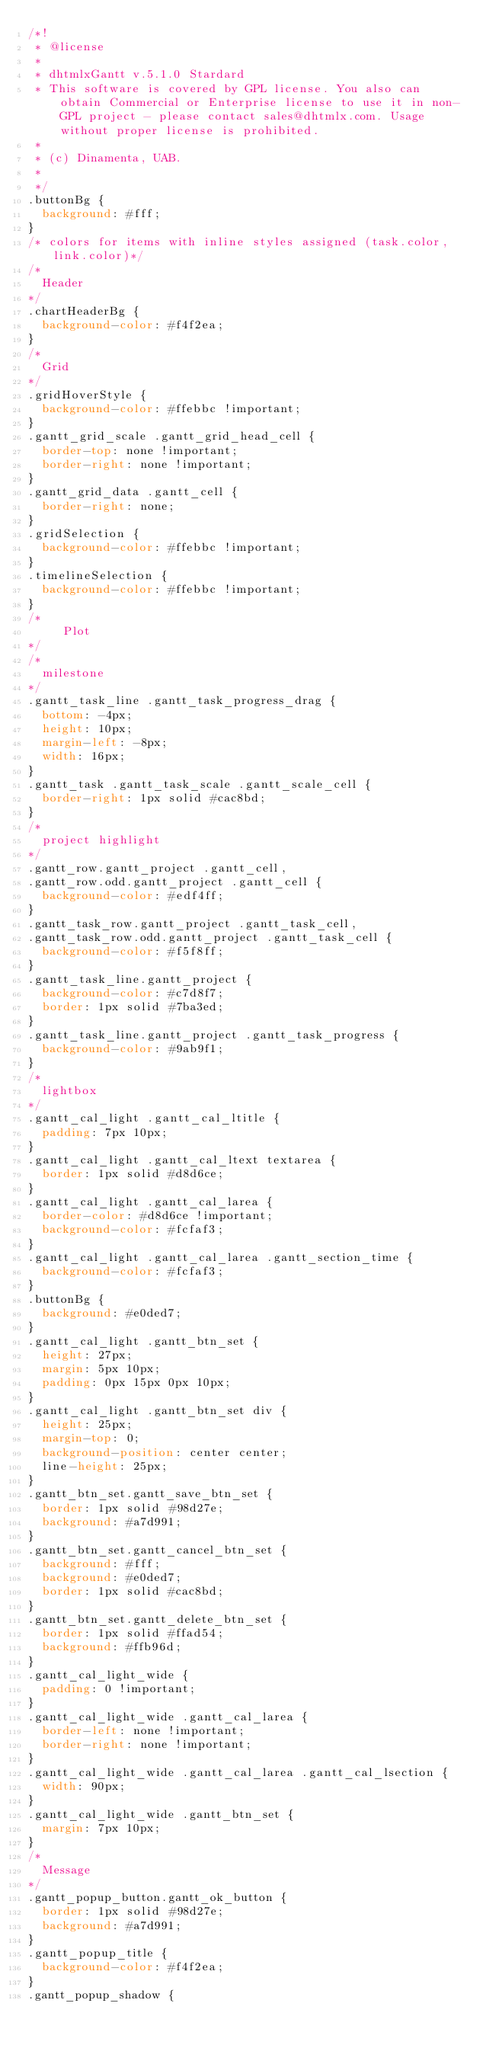<code> <loc_0><loc_0><loc_500><loc_500><_CSS_>/*!
 * @license
 * 
 * dhtmlxGantt v.5.1.0 Stardard
 * This software is covered by GPL license. You also can obtain Commercial or Enterprise license to use it in non-GPL project - please contact sales@dhtmlx.com. Usage without proper license is prohibited.
 * 
 * (c) Dinamenta, UAB.
 * 
 */
.buttonBg {
  background: #fff;
}
/* colors for items with inline styles assigned (task.color, link.color)*/
/*
	Header
*/
.chartHeaderBg {
  background-color: #f4f2ea;
}
/*
	Grid
*/
.gridHoverStyle {
  background-color: #ffebbc !important;
}
.gantt_grid_scale .gantt_grid_head_cell {
  border-top: none !important;
  border-right: none !important;
}
.gantt_grid_data .gantt_cell {
  border-right: none;
}
.gridSelection {
  background-color: #ffebbc !important;
}
.timelineSelection {
  background-color: #ffebbc !important;
}
/*
     Plot
*/
/*
	milestone
*/
.gantt_task_line .gantt_task_progress_drag {
  bottom: -4px;
  height: 10px;
  margin-left: -8px;
  width: 16px;
}
.gantt_task .gantt_task_scale .gantt_scale_cell {
  border-right: 1px solid #cac8bd;
}
/*
	project highlight
*/
.gantt_row.gantt_project .gantt_cell,
.gantt_row.odd.gantt_project .gantt_cell {
  background-color: #edf4ff;
}
.gantt_task_row.gantt_project .gantt_task_cell,
.gantt_task_row.odd.gantt_project .gantt_task_cell {
  background-color: #f5f8ff;
}
.gantt_task_line.gantt_project {
  background-color: #c7d8f7;
  border: 1px solid #7ba3ed;
}
.gantt_task_line.gantt_project .gantt_task_progress {
  background-color: #9ab9f1;
}
/*
	lightbox
*/
.gantt_cal_light .gantt_cal_ltitle {
  padding: 7px 10px;
}
.gantt_cal_light .gantt_cal_ltext textarea {
  border: 1px solid #d8d6ce;
}
.gantt_cal_light .gantt_cal_larea {
  border-color: #d8d6ce !important;
  background-color: #fcfaf3;
}
.gantt_cal_light .gantt_cal_larea .gantt_section_time {
  background-color: #fcfaf3;
}
.buttonBg {
  background: #e0ded7;
}
.gantt_cal_light .gantt_btn_set {
  height: 27px;
  margin: 5px 10px;
  padding: 0px 15px 0px 10px;
}
.gantt_cal_light .gantt_btn_set div {
  height: 25px;
  margin-top: 0;
  background-position: center center;
  line-height: 25px;
}
.gantt_btn_set.gantt_save_btn_set {
  border: 1px solid #98d27e;
  background: #a7d991;
}
.gantt_btn_set.gantt_cancel_btn_set {
  background: #fff;
  background: #e0ded7;
  border: 1px solid #cac8bd;
}
.gantt_btn_set.gantt_delete_btn_set {
  border: 1px solid #ffad54;
  background: #ffb96d;
}
.gantt_cal_light_wide {
  padding: 0 !important;
}
.gantt_cal_light_wide .gantt_cal_larea {
  border-left: none !important;
  border-right: none !important;
}
.gantt_cal_light_wide .gantt_cal_larea .gantt_cal_lsection {
  width: 90px;
}
.gantt_cal_light_wide .gantt_btn_set {
  margin: 7px 10px;
}
/*
	Message
*/
.gantt_popup_button.gantt_ok_button {
  border: 1px solid #98d27e;
  background: #a7d991;
}
.gantt_popup_title {
  background-color: #f4f2ea;
}
.gantt_popup_shadow {</code> 